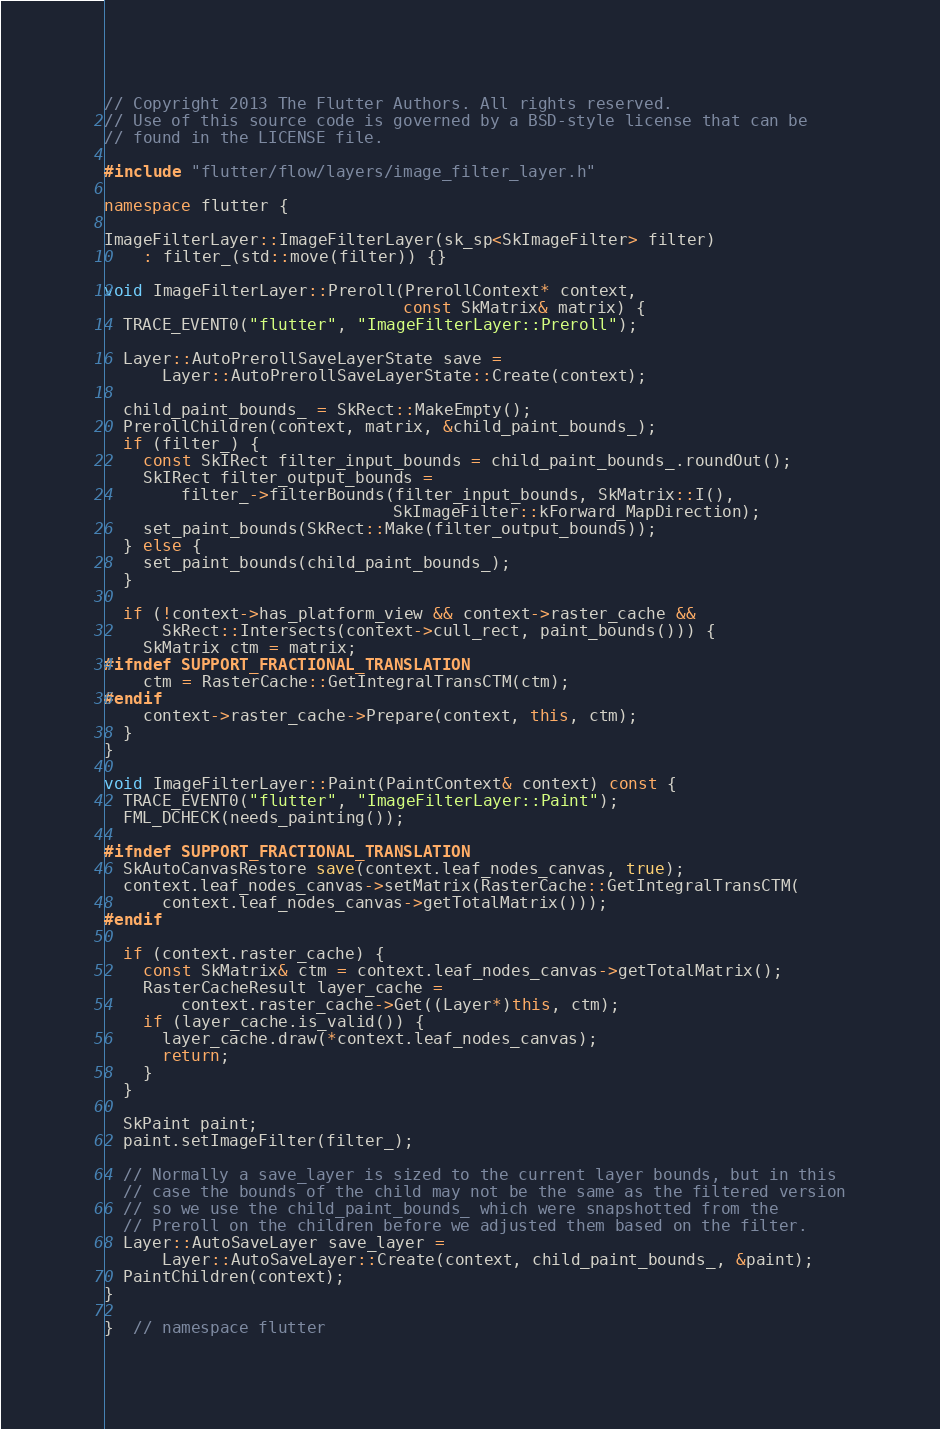Convert code to text. <code><loc_0><loc_0><loc_500><loc_500><_C++_>// Copyright 2013 The Flutter Authors. All rights reserved.
// Use of this source code is governed by a BSD-style license that can be
// found in the LICENSE file.

#include "flutter/flow/layers/image_filter_layer.h"

namespace flutter {

ImageFilterLayer::ImageFilterLayer(sk_sp<SkImageFilter> filter)
    : filter_(std::move(filter)) {}

void ImageFilterLayer::Preroll(PrerollContext* context,
                               const SkMatrix& matrix) {
  TRACE_EVENT0("flutter", "ImageFilterLayer::Preroll");

  Layer::AutoPrerollSaveLayerState save =
      Layer::AutoPrerollSaveLayerState::Create(context);

  child_paint_bounds_ = SkRect::MakeEmpty();
  PrerollChildren(context, matrix, &child_paint_bounds_);
  if (filter_) {
    const SkIRect filter_input_bounds = child_paint_bounds_.roundOut();
    SkIRect filter_output_bounds =
        filter_->filterBounds(filter_input_bounds, SkMatrix::I(),
                              SkImageFilter::kForward_MapDirection);
    set_paint_bounds(SkRect::Make(filter_output_bounds));
  } else {
    set_paint_bounds(child_paint_bounds_);
  }

  if (!context->has_platform_view && context->raster_cache &&
      SkRect::Intersects(context->cull_rect, paint_bounds())) {
    SkMatrix ctm = matrix;
#ifndef SUPPORT_FRACTIONAL_TRANSLATION
    ctm = RasterCache::GetIntegralTransCTM(ctm);
#endif
    context->raster_cache->Prepare(context, this, ctm);
  }
}

void ImageFilterLayer::Paint(PaintContext& context) const {
  TRACE_EVENT0("flutter", "ImageFilterLayer::Paint");
  FML_DCHECK(needs_painting());

#ifndef SUPPORT_FRACTIONAL_TRANSLATION
  SkAutoCanvasRestore save(context.leaf_nodes_canvas, true);
  context.leaf_nodes_canvas->setMatrix(RasterCache::GetIntegralTransCTM(
      context.leaf_nodes_canvas->getTotalMatrix()));
#endif

  if (context.raster_cache) {
    const SkMatrix& ctm = context.leaf_nodes_canvas->getTotalMatrix();
    RasterCacheResult layer_cache =
        context.raster_cache->Get((Layer*)this, ctm);
    if (layer_cache.is_valid()) {
      layer_cache.draw(*context.leaf_nodes_canvas);
      return;
    }
  }

  SkPaint paint;
  paint.setImageFilter(filter_);

  // Normally a save_layer is sized to the current layer bounds, but in this
  // case the bounds of the child may not be the same as the filtered version
  // so we use the child_paint_bounds_ which were snapshotted from the
  // Preroll on the children before we adjusted them based on the filter.
  Layer::AutoSaveLayer save_layer =
      Layer::AutoSaveLayer::Create(context, child_paint_bounds_, &paint);
  PaintChildren(context);
}

}  // namespace flutter
</code> 